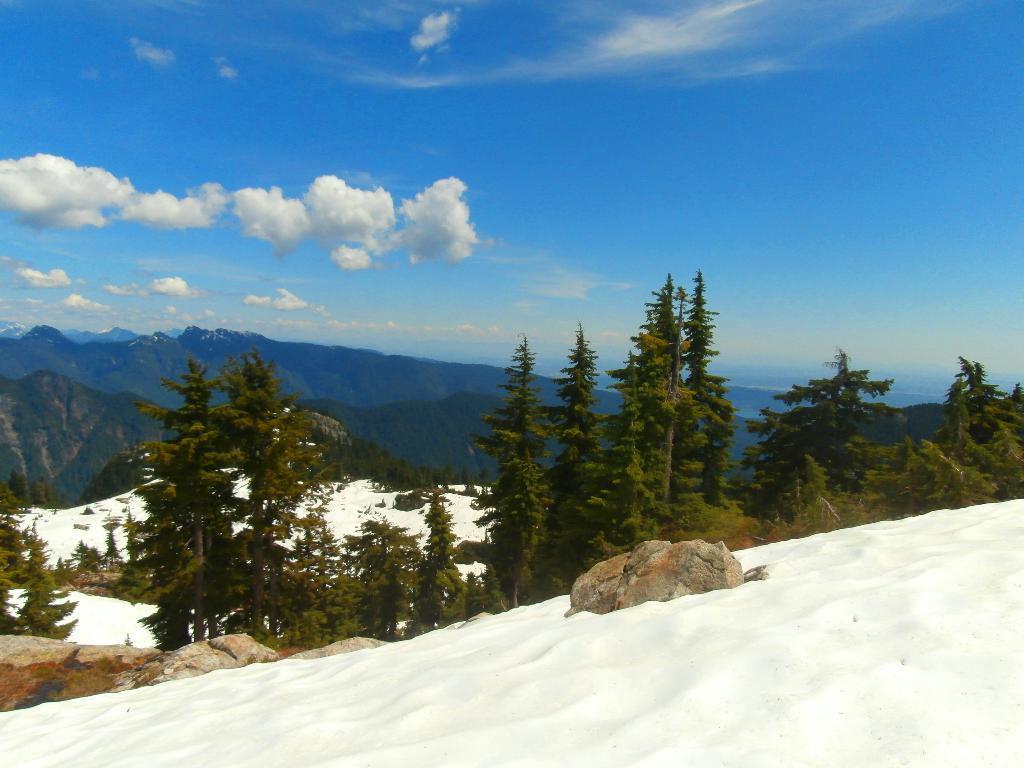Describe this image in one or two sentences. In the image there is a snow surface in the foreground and behind the snow surface there are trees and in the background there are mountains. 